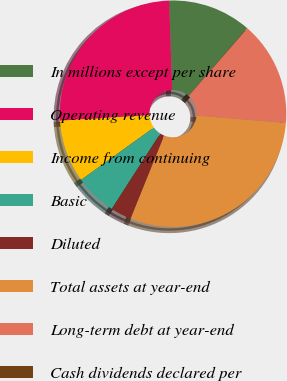Convert chart to OTSL. <chart><loc_0><loc_0><loc_500><loc_500><pie_chart><fcel>In millions except per share<fcel>Operating revenue<fcel>Income from continuing<fcel>Basic<fcel>Diluted<fcel>Total assets at year-end<fcel>Long-term debt at year-end<fcel>Cash dividends declared per<nl><fcel>11.93%<fcel>25.43%<fcel>8.95%<fcel>5.97%<fcel>2.99%<fcel>29.82%<fcel>14.91%<fcel>0.01%<nl></chart> 